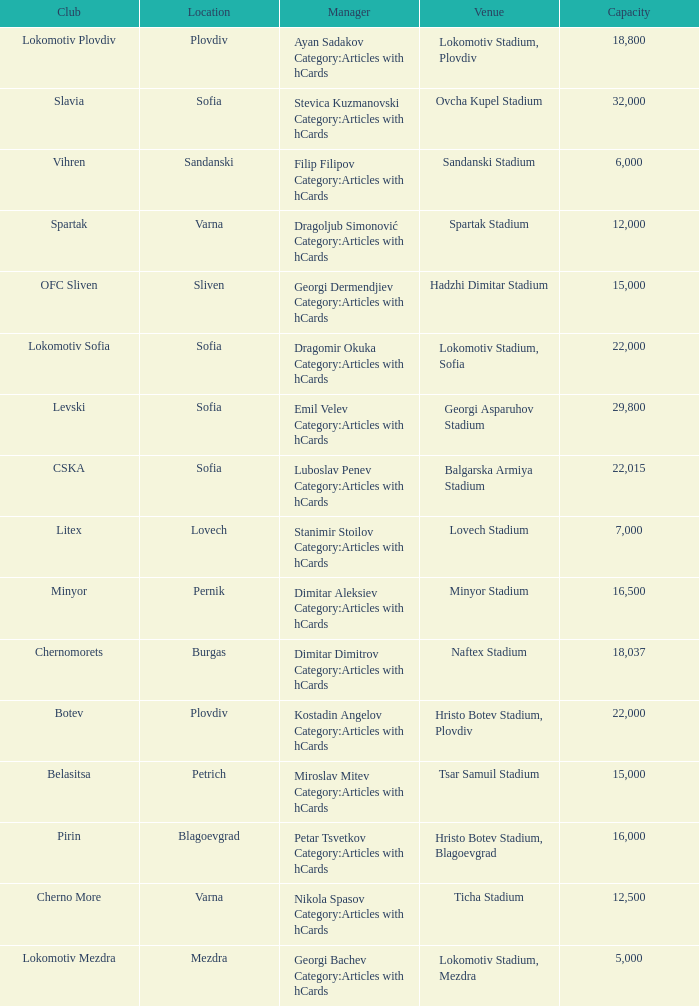What is the total number of capacity for the venue of the club, pirin? 1.0. 